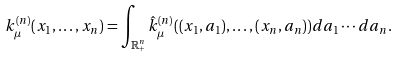Convert formula to latex. <formula><loc_0><loc_0><loc_500><loc_500>k _ { \mu } ^ { ( n ) } ( x _ { 1 } , \dots , x _ { n } ) = \int _ { \mathbb { R } _ { + } ^ { n } } \hat { k } _ { \mu } ^ { ( n ) } ( ( x _ { 1 } , a _ { 1 } ) , \dots , ( x _ { n } , a _ { n } ) ) d a _ { 1 } \cdots d a _ { n } .</formula> 